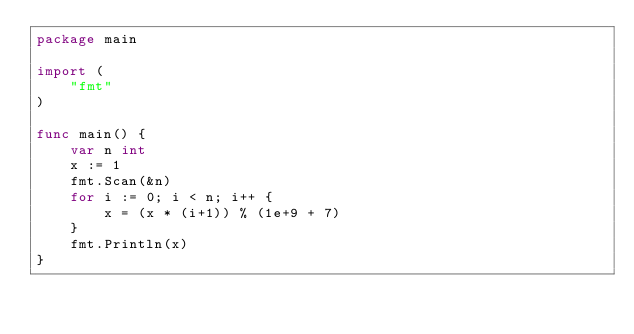Convert code to text. <code><loc_0><loc_0><loc_500><loc_500><_Go_>package main

import (
	"fmt"
)

func main() {
	var n int
	x := 1
	fmt.Scan(&n)
	for i := 0; i < n; i++ {
		x = (x * (i+1)) % (1e+9 + 7)
	}
	fmt.Println(x)
}
</code> 